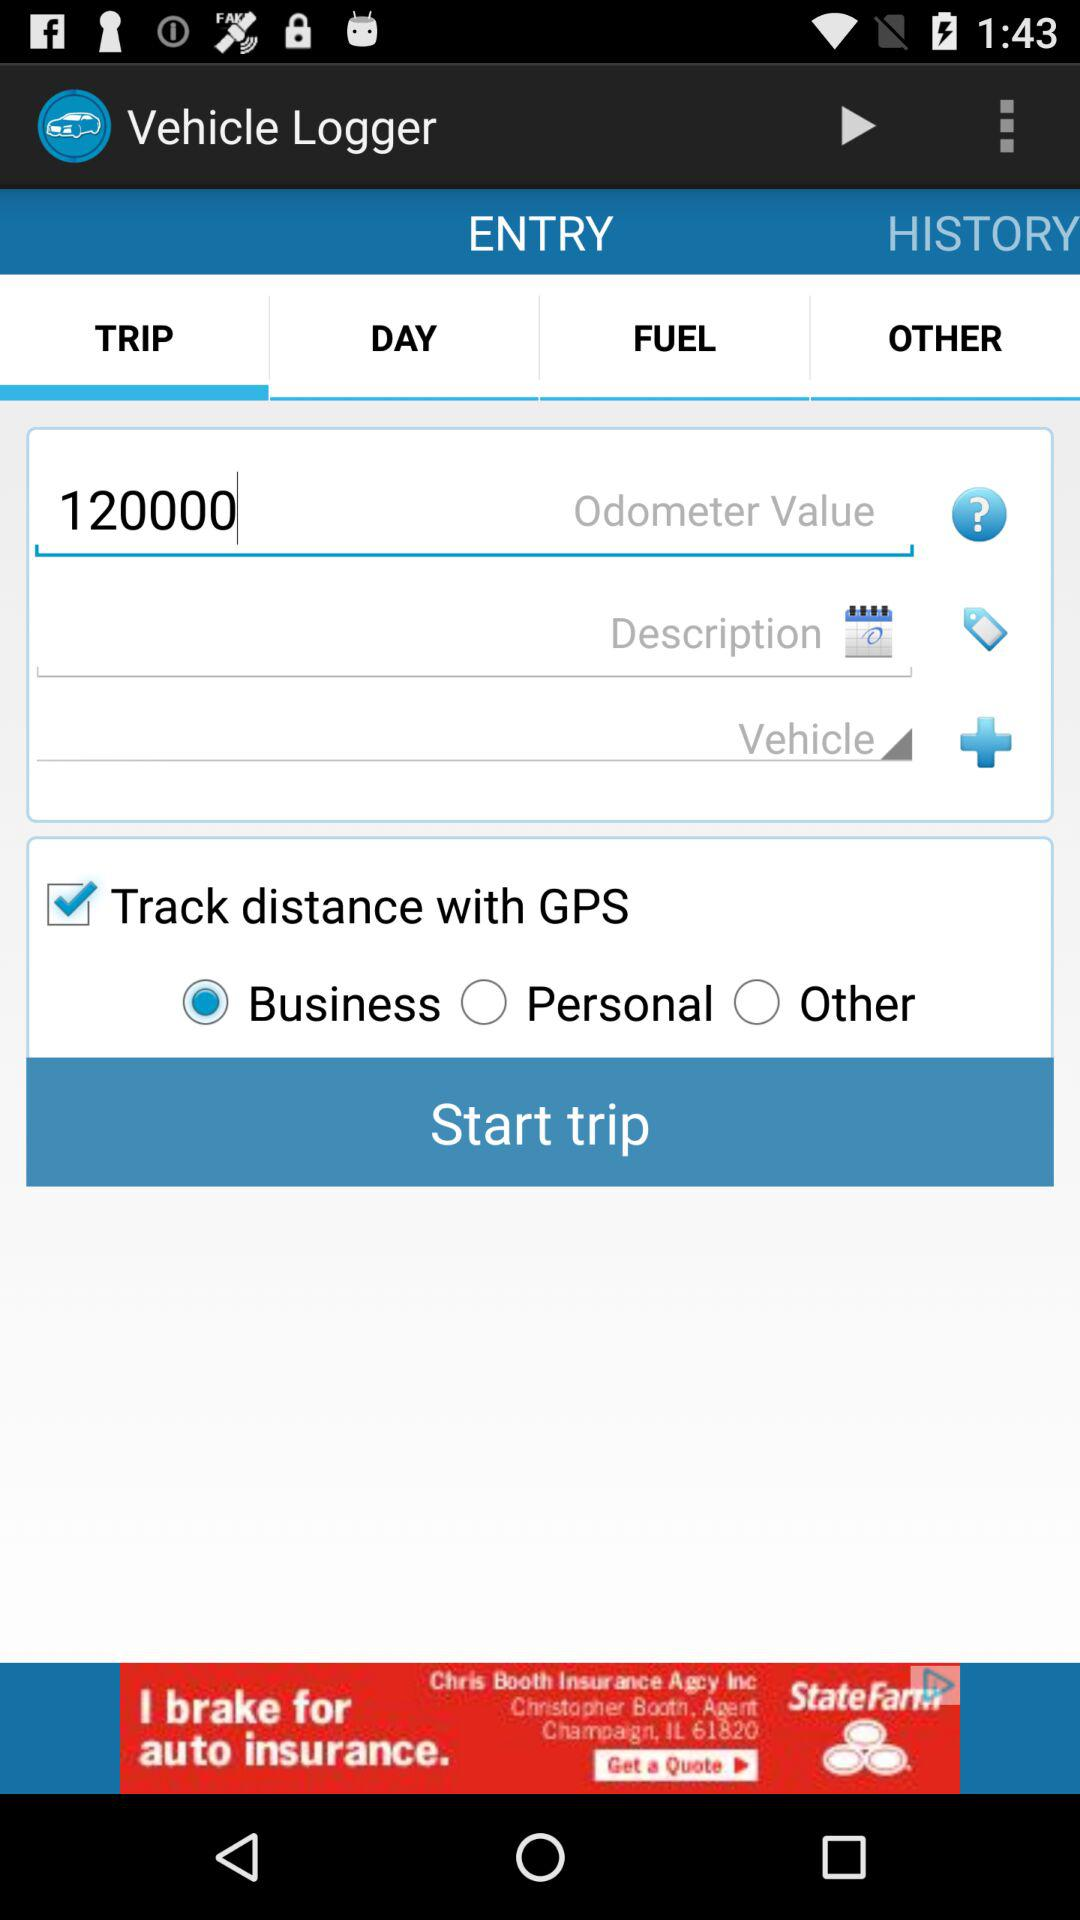What type of vehicle was used?
When the provided information is insufficient, respond with <no answer>. <no answer> 